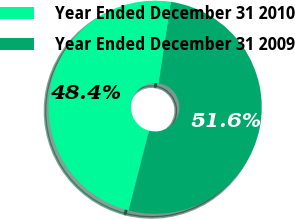Convert chart to OTSL. <chart><loc_0><loc_0><loc_500><loc_500><pie_chart><fcel>Year Ended December 31 2010<fcel>Year Ended December 31 2009<nl><fcel>48.4%<fcel>51.6%<nl></chart> 